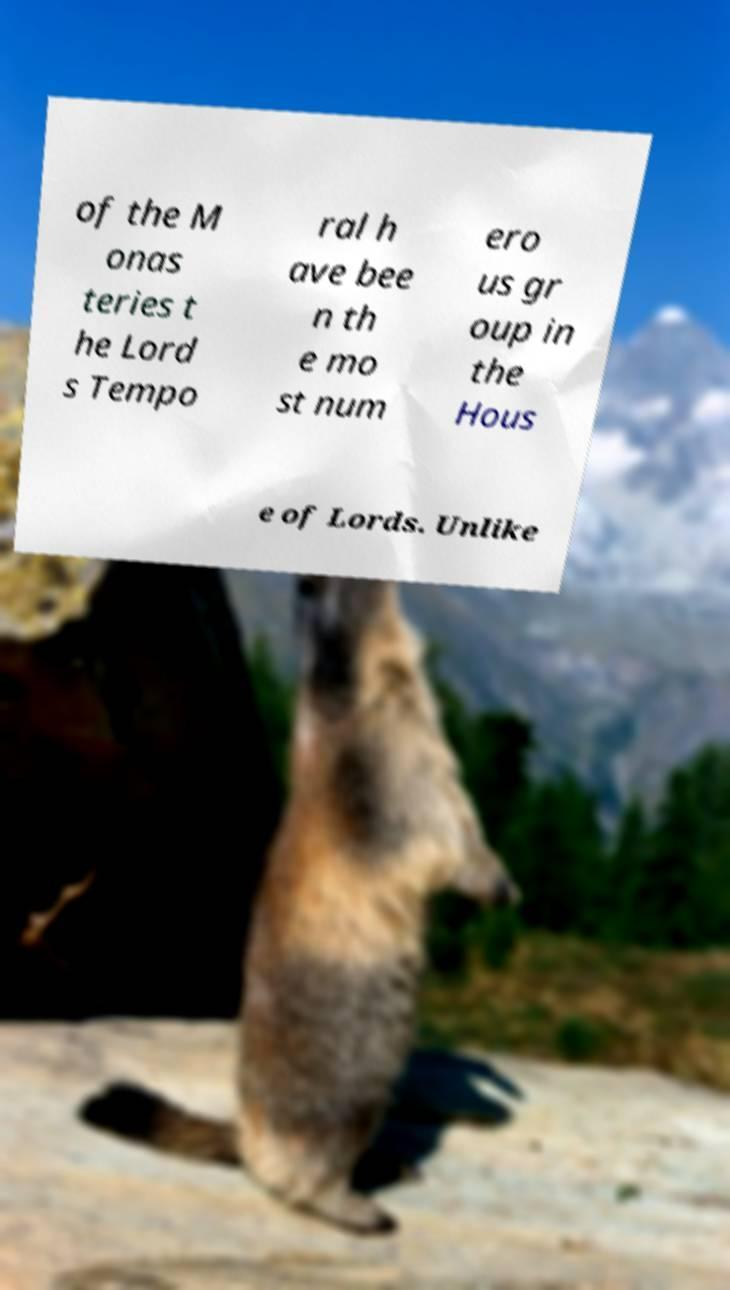Could you assist in decoding the text presented in this image and type it out clearly? of the M onas teries t he Lord s Tempo ral h ave bee n th e mo st num ero us gr oup in the Hous e of Lords. Unlike 